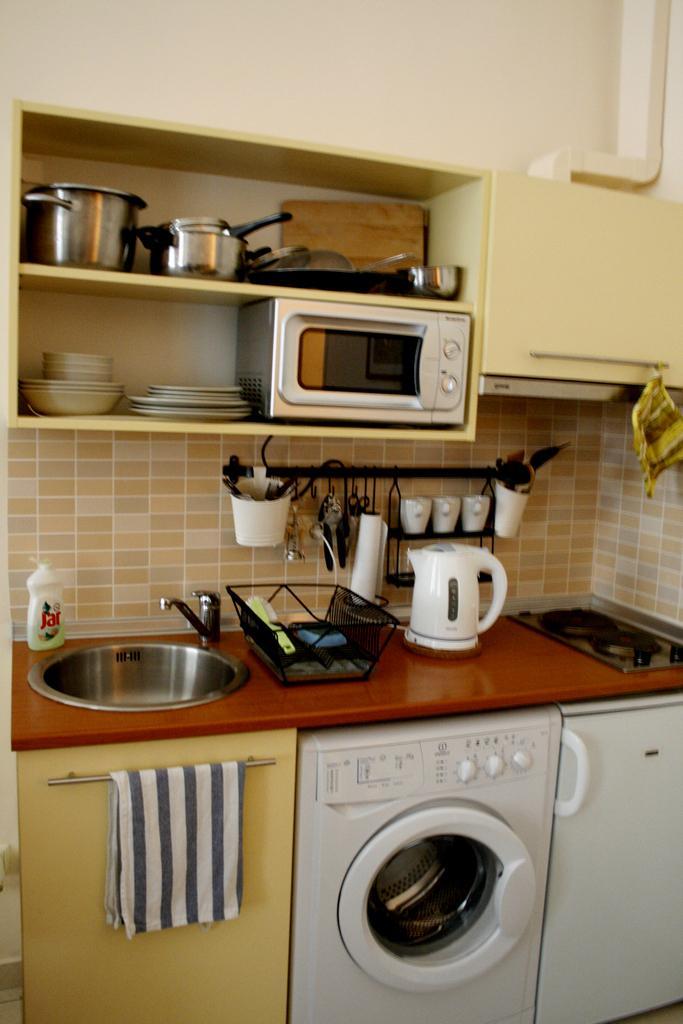Could you give a brief overview of what you see in this image? In the image we can see the kitchen. This is a basin, water tap, hand wash, jug, cups, napkin, stove, washbasin, basket, knife and spoons, oven, plate and containers. 